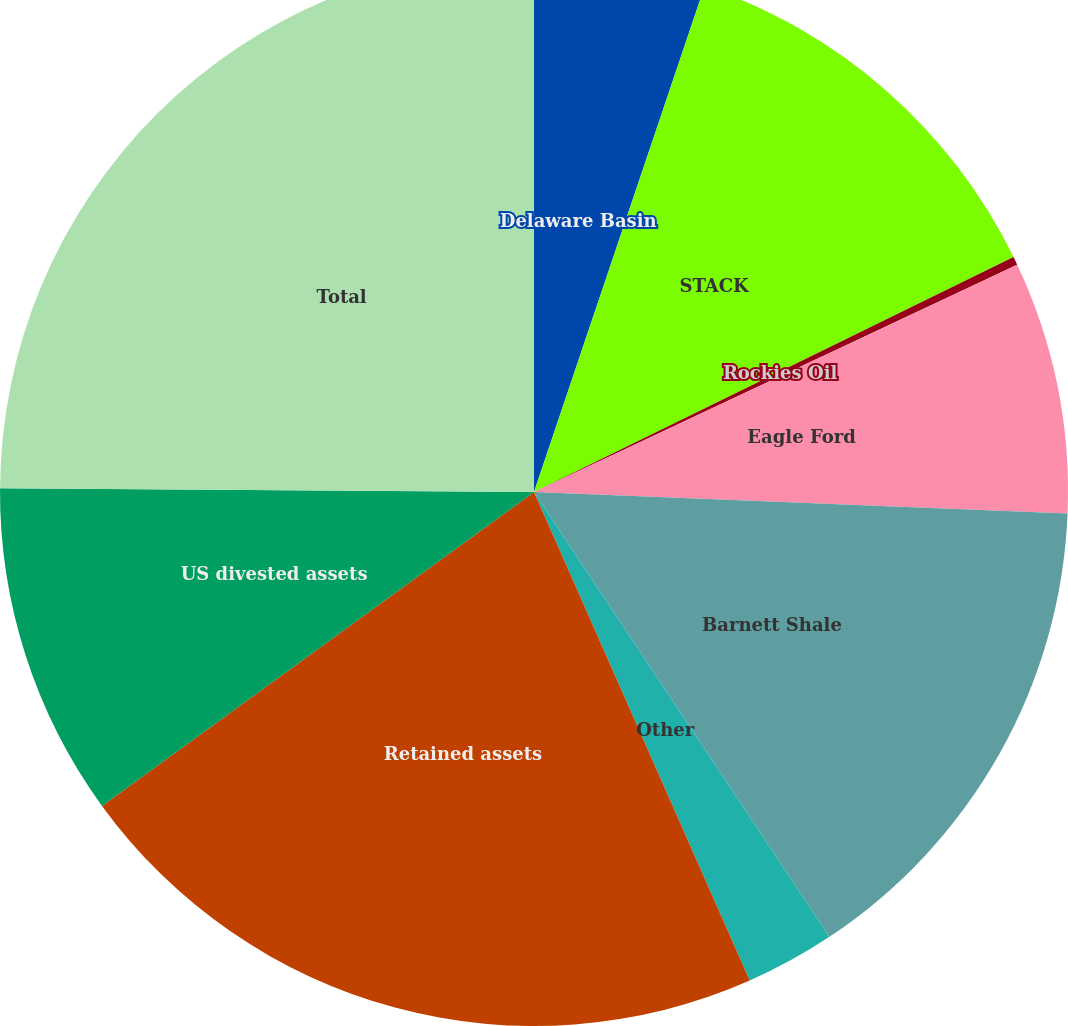Convert chart. <chart><loc_0><loc_0><loc_500><loc_500><pie_chart><fcel>Delaware Basin<fcel>STACK<fcel>Rockies Oil<fcel>Eagle Ford<fcel>Barnett Shale<fcel>Other<fcel>Retained assets<fcel>US divested assets<fcel>Total<nl><fcel>5.18%<fcel>12.57%<fcel>0.25%<fcel>7.64%<fcel>15.03%<fcel>2.71%<fcel>21.62%<fcel>10.11%<fcel>24.89%<nl></chart> 